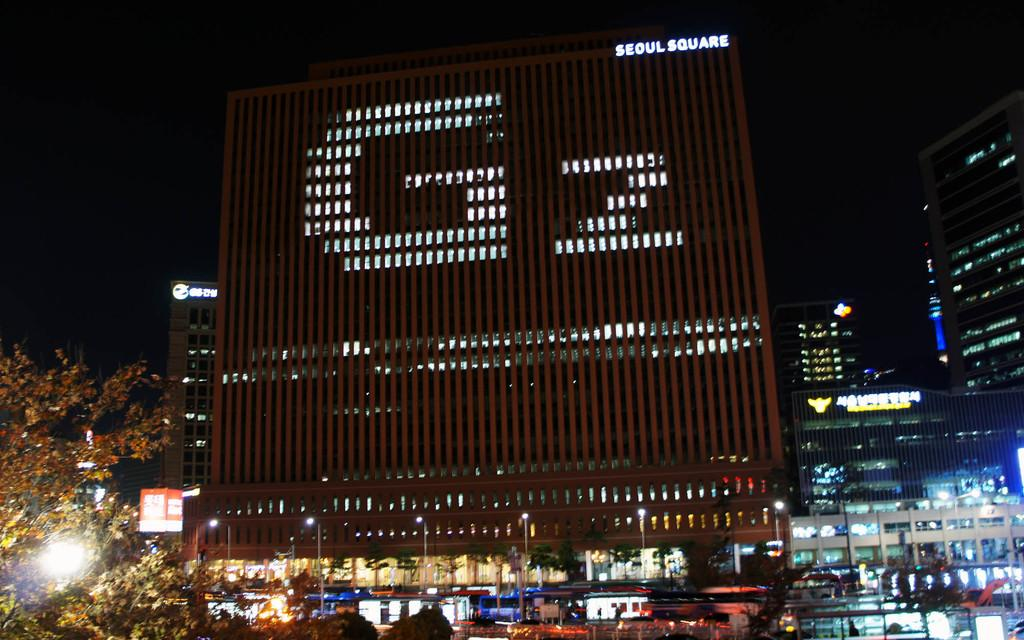What is the main subject in the image? There is a hoarding in the image. What other elements can be seen in the image besides the hoarding? There are trees, lights on poles, and buildings visible in the background of the image. What is visible in the sky in the image? The sky is visible in the background of the image. Can you hear the rabbits making noise in the image? There are no rabbits present in the image, so it is not possible to hear any noise they might make. 